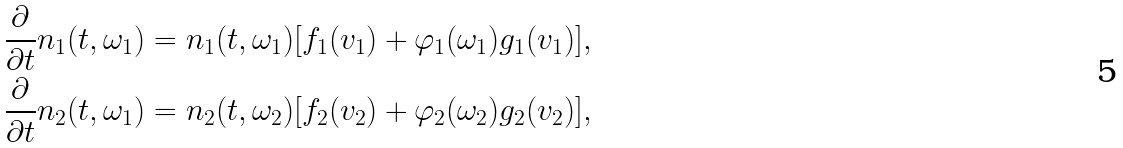<formula> <loc_0><loc_0><loc_500><loc_500>\frac { \partial } { \partial t } n _ { 1 } ( t , \omega _ { 1 } ) & = n _ { 1 } ( t , \omega _ { 1 } ) [ f _ { 1 } ( v _ { 1 } ) + \varphi _ { 1 } ( \omega _ { 1 } ) g _ { 1 } ( v _ { 1 } ) ] , \\ \frac { \partial } { \partial t } n _ { 2 } ( t , \omega _ { 1 } ) & = n _ { 2 } ( t , \omega _ { 2 } ) [ f _ { 2 } ( v _ { 2 } ) + \varphi _ { 2 } ( \omega _ { 2 } ) g _ { 2 } ( v _ { 2 } ) ] ,</formula> 